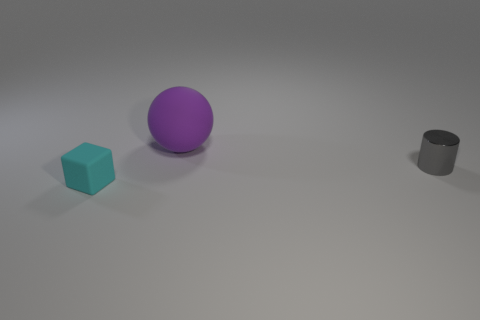Does the metallic thing have the same shape as the tiny rubber thing?
Your answer should be very brief. No. What material is the thing that is behind the rubber block and in front of the large object?
Offer a very short reply. Metal. How big is the thing to the left of the rubber thing that is behind the small object on the right side of the small cyan rubber block?
Offer a terse response. Small. Is the number of purple balls right of the cyan matte thing greater than the number of cyan matte cubes?
Offer a terse response. No. Are any small cyan rubber cubes visible?
Ensure brevity in your answer.  Yes. What number of rubber objects are the same size as the matte sphere?
Offer a very short reply. 0. Are there more tiny rubber things that are behind the rubber sphere than tiny gray shiny things to the left of the gray object?
Keep it short and to the point. No. There is a gray object that is the same size as the cyan cube; what material is it?
Provide a short and direct response. Metal. What shape is the small gray metallic object?
Provide a succinct answer. Cylinder. What number of purple objects are metallic things or big rubber spheres?
Your answer should be compact. 1. 